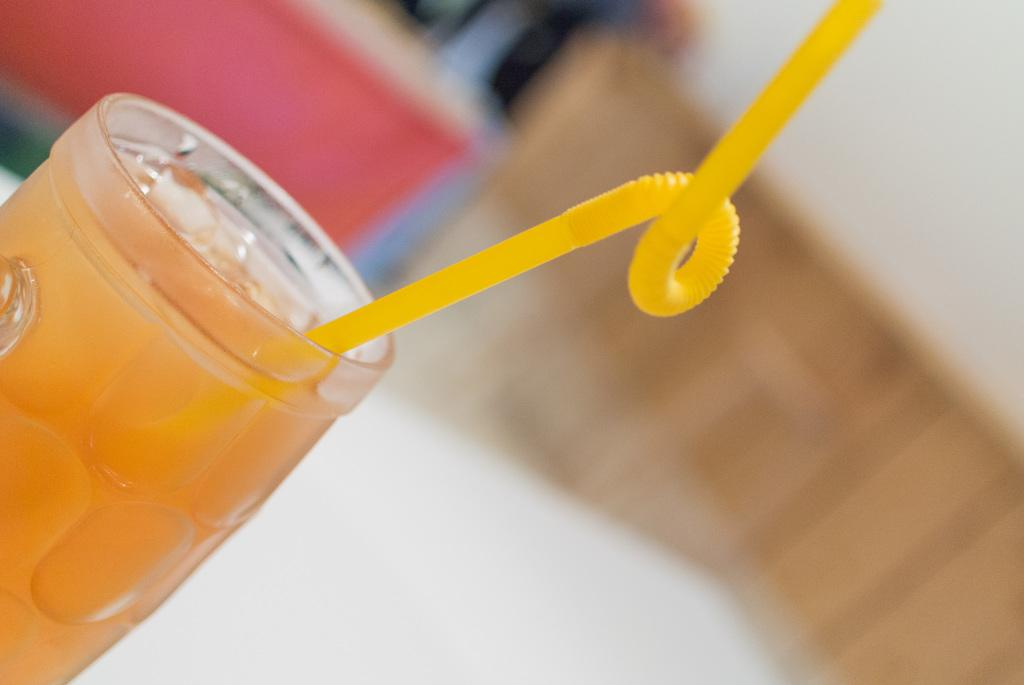What is located on the left side of the image? There is a glass on the left side of the image. What is inside the glass? The glass contains a drink. How might someone consume the drink in the glass? There is a straw in the glass, which can be used for drinking. What type of animals can be seen at the zoo in the image? There is no zoo present in the image; it features a glass with a drink and a straw. 